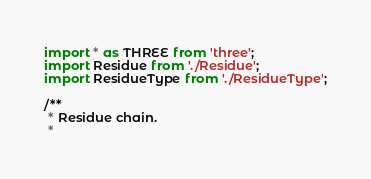Convert code to text. <code><loc_0><loc_0><loc_500><loc_500><_JavaScript_>import * as THREE from 'three';
import Residue from './Residue';
import ResidueType from './ResidueType';

/**
 * Residue chain.
 *</code> 